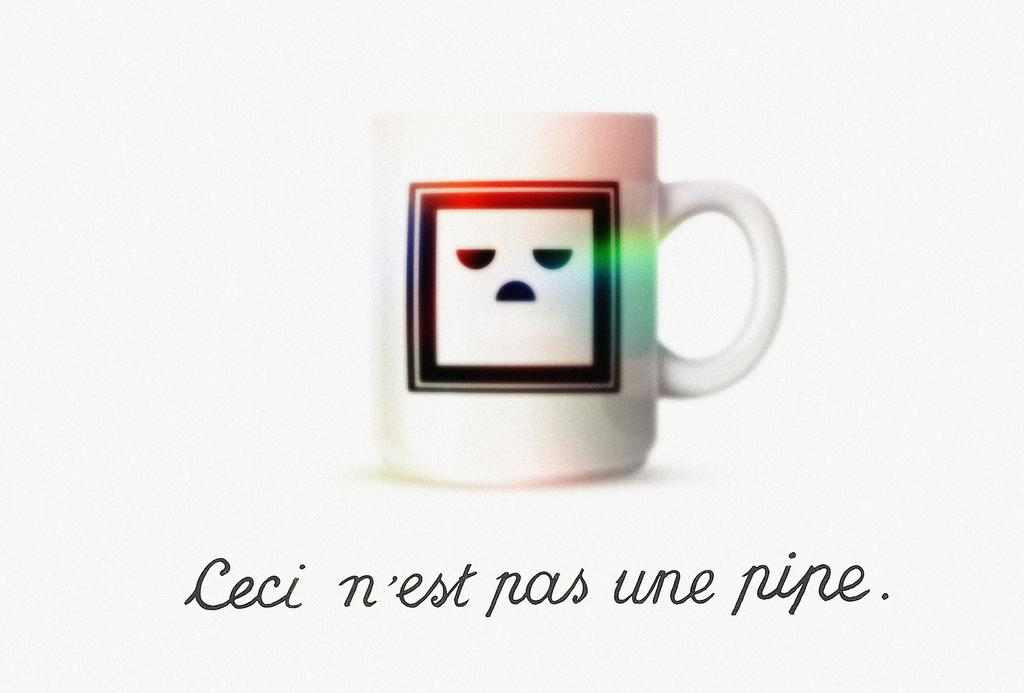<image>
Relay a brief, clear account of the picture shown. A coffee cup with Ceci n'est pas une pipe under it. 